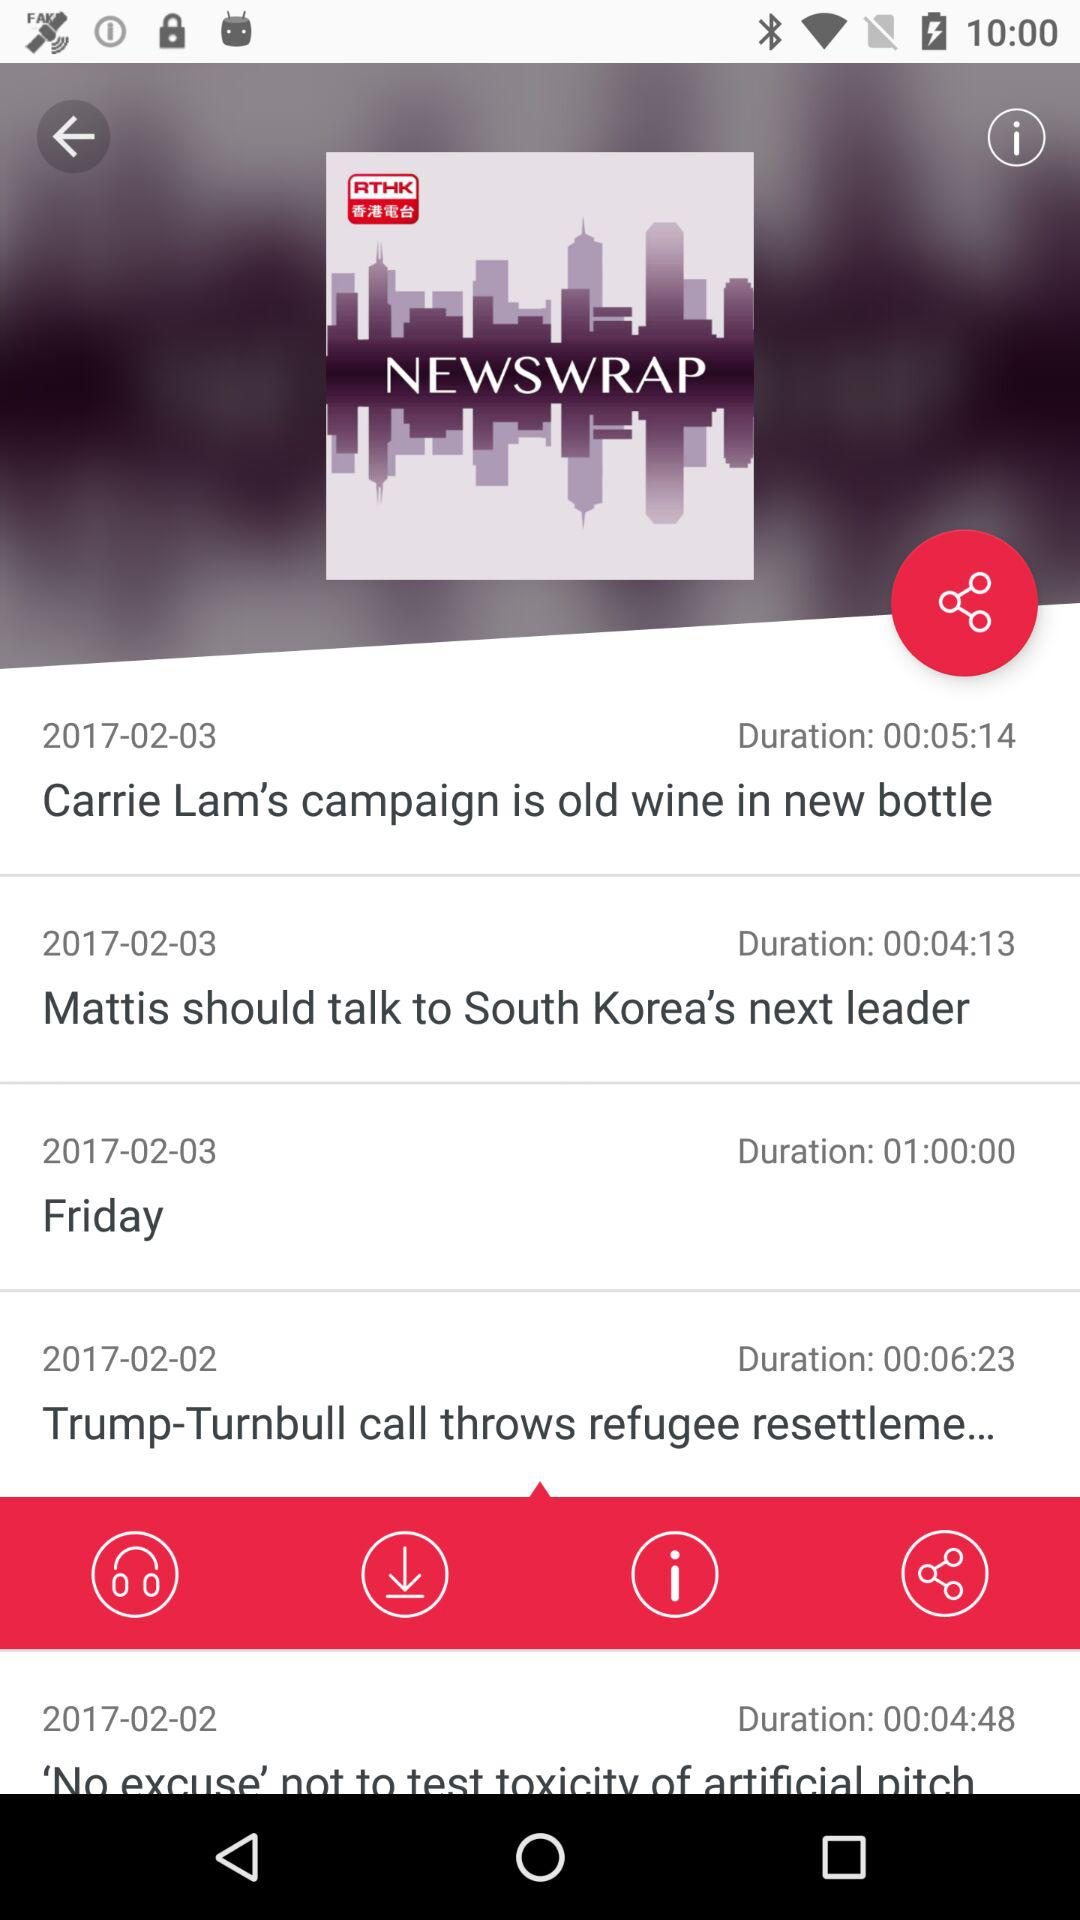How long will the news "Friday" be broadcast? The news "Friday" will be broadcast for 1 hour. 